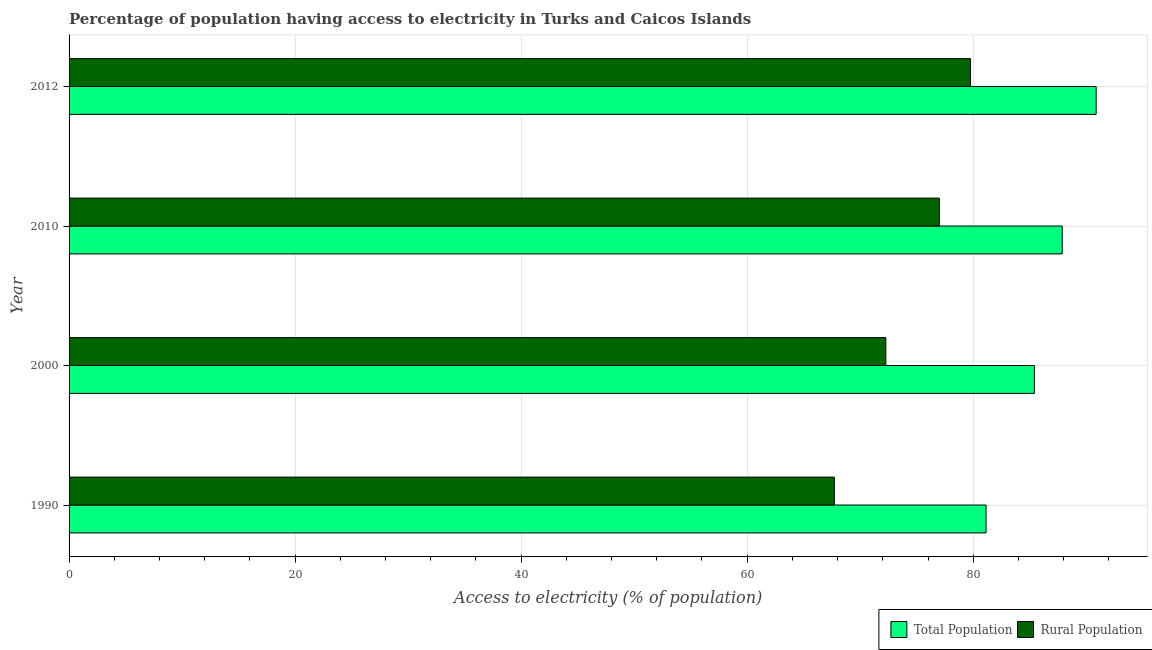How many groups of bars are there?
Give a very brief answer. 4. Are the number of bars on each tick of the Y-axis equal?
Your response must be concise. Yes. How many bars are there on the 2nd tick from the top?
Offer a very short reply. 2. How many bars are there on the 2nd tick from the bottom?
Keep it short and to the point. 2. What is the label of the 3rd group of bars from the top?
Offer a terse response. 2000. What is the percentage of rural population having access to electricity in 2010?
Provide a succinct answer. 77. Across all years, what is the maximum percentage of rural population having access to electricity?
Offer a terse response. 79.75. Across all years, what is the minimum percentage of population having access to electricity?
Keep it short and to the point. 81.14. In which year was the percentage of rural population having access to electricity minimum?
Keep it short and to the point. 1990. What is the total percentage of population having access to electricity in the graph?
Your answer should be compact. 345.3. What is the difference between the percentage of population having access to electricity in 1990 and that in 2000?
Your response must be concise. -4.28. What is the difference between the percentage of population having access to electricity in 2000 and the percentage of rural population having access to electricity in 2012?
Your answer should be very brief. 5.66. What is the average percentage of population having access to electricity per year?
Your response must be concise. 86.32. In the year 2000, what is the difference between the percentage of rural population having access to electricity and percentage of population having access to electricity?
Your answer should be compact. -13.15. In how many years, is the percentage of population having access to electricity greater than 60 %?
Give a very brief answer. 4. What is the ratio of the percentage of rural population having access to electricity in 1990 to that in 2012?
Your answer should be compact. 0.85. Is the percentage of rural population having access to electricity in 1990 less than that in 2000?
Give a very brief answer. Yes. Is the difference between the percentage of rural population having access to electricity in 1990 and 2010 greater than the difference between the percentage of population having access to electricity in 1990 and 2010?
Ensure brevity in your answer.  No. What is the difference between the highest and the second highest percentage of population having access to electricity?
Your response must be concise. 3. What is the difference between the highest and the lowest percentage of population having access to electricity?
Offer a very short reply. 9.74. In how many years, is the percentage of population having access to electricity greater than the average percentage of population having access to electricity taken over all years?
Your response must be concise. 2. What does the 2nd bar from the top in 2000 represents?
Offer a very short reply. Total Population. What does the 2nd bar from the bottom in 1990 represents?
Your response must be concise. Rural Population. How many years are there in the graph?
Your answer should be very brief. 4. Are the values on the major ticks of X-axis written in scientific E-notation?
Make the answer very short. No. Does the graph contain any zero values?
Keep it short and to the point. No. Does the graph contain grids?
Make the answer very short. Yes. How many legend labels are there?
Offer a very short reply. 2. How are the legend labels stacked?
Your response must be concise. Horizontal. What is the title of the graph?
Keep it short and to the point. Percentage of population having access to electricity in Turks and Caicos Islands. What is the label or title of the X-axis?
Offer a very short reply. Access to electricity (% of population). What is the label or title of the Y-axis?
Ensure brevity in your answer.  Year. What is the Access to electricity (% of population) of Total Population in 1990?
Provide a short and direct response. 81.14. What is the Access to electricity (% of population) of Rural Population in 1990?
Offer a very short reply. 67.71. What is the Access to electricity (% of population) in Total Population in 2000?
Your answer should be compact. 85.41. What is the Access to electricity (% of population) in Rural Population in 2000?
Give a very brief answer. 72.27. What is the Access to electricity (% of population) in Total Population in 2010?
Your answer should be very brief. 87.87. What is the Access to electricity (% of population) of Total Population in 2012?
Ensure brevity in your answer.  90.88. What is the Access to electricity (% of population) in Rural Population in 2012?
Keep it short and to the point. 79.75. Across all years, what is the maximum Access to electricity (% of population) of Total Population?
Make the answer very short. 90.88. Across all years, what is the maximum Access to electricity (% of population) in Rural Population?
Make the answer very short. 79.75. Across all years, what is the minimum Access to electricity (% of population) in Total Population?
Offer a very short reply. 81.14. Across all years, what is the minimum Access to electricity (% of population) of Rural Population?
Your response must be concise. 67.71. What is the total Access to electricity (% of population) of Total Population in the graph?
Keep it short and to the point. 345.3. What is the total Access to electricity (% of population) of Rural Population in the graph?
Provide a succinct answer. 296.73. What is the difference between the Access to electricity (% of population) in Total Population in 1990 and that in 2000?
Keep it short and to the point. -4.28. What is the difference between the Access to electricity (% of population) in Rural Population in 1990 and that in 2000?
Your answer should be very brief. -4.55. What is the difference between the Access to electricity (% of population) of Total Population in 1990 and that in 2010?
Your answer should be very brief. -6.74. What is the difference between the Access to electricity (% of population) of Rural Population in 1990 and that in 2010?
Your answer should be compact. -9.29. What is the difference between the Access to electricity (% of population) in Total Population in 1990 and that in 2012?
Keep it short and to the point. -9.74. What is the difference between the Access to electricity (% of population) in Rural Population in 1990 and that in 2012?
Provide a short and direct response. -12.04. What is the difference between the Access to electricity (% of population) in Total Population in 2000 and that in 2010?
Make the answer very short. -2.46. What is the difference between the Access to electricity (% of population) of Rural Population in 2000 and that in 2010?
Make the answer very short. -4.74. What is the difference between the Access to electricity (% of population) of Total Population in 2000 and that in 2012?
Offer a terse response. -5.46. What is the difference between the Access to electricity (% of population) of Rural Population in 2000 and that in 2012?
Ensure brevity in your answer.  -7.49. What is the difference between the Access to electricity (% of population) in Total Population in 2010 and that in 2012?
Provide a succinct answer. -3. What is the difference between the Access to electricity (% of population) in Rural Population in 2010 and that in 2012?
Provide a short and direct response. -2.75. What is the difference between the Access to electricity (% of population) in Total Population in 1990 and the Access to electricity (% of population) in Rural Population in 2000?
Your answer should be very brief. 8.87. What is the difference between the Access to electricity (% of population) in Total Population in 1990 and the Access to electricity (% of population) in Rural Population in 2010?
Offer a terse response. 4.14. What is the difference between the Access to electricity (% of population) of Total Population in 1990 and the Access to electricity (% of population) of Rural Population in 2012?
Offer a terse response. 1.38. What is the difference between the Access to electricity (% of population) in Total Population in 2000 and the Access to electricity (% of population) in Rural Population in 2010?
Your answer should be very brief. 8.41. What is the difference between the Access to electricity (% of population) in Total Population in 2000 and the Access to electricity (% of population) in Rural Population in 2012?
Offer a very short reply. 5.66. What is the difference between the Access to electricity (% of population) of Total Population in 2010 and the Access to electricity (% of population) of Rural Population in 2012?
Offer a very short reply. 8.12. What is the average Access to electricity (% of population) in Total Population per year?
Provide a succinct answer. 86.32. What is the average Access to electricity (% of population) of Rural Population per year?
Offer a very short reply. 74.18. In the year 1990, what is the difference between the Access to electricity (% of population) in Total Population and Access to electricity (% of population) in Rural Population?
Offer a very short reply. 13.42. In the year 2000, what is the difference between the Access to electricity (% of population) of Total Population and Access to electricity (% of population) of Rural Population?
Your response must be concise. 13.15. In the year 2010, what is the difference between the Access to electricity (% of population) of Total Population and Access to electricity (% of population) of Rural Population?
Provide a short and direct response. 10.87. In the year 2012, what is the difference between the Access to electricity (% of population) of Total Population and Access to electricity (% of population) of Rural Population?
Ensure brevity in your answer.  11.12. What is the ratio of the Access to electricity (% of population) in Total Population in 1990 to that in 2000?
Give a very brief answer. 0.95. What is the ratio of the Access to electricity (% of population) of Rural Population in 1990 to that in 2000?
Offer a very short reply. 0.94. What is the ratio of the Access to electricity (% of population) of Total Population in 1990 to that in 2010?
Offer a terse response. 0.92. What is the ratio of the Access to electricity (% of population) of Rural Population in 1990 to that in 2010?
Make the answer very short. 0.88. What is the ratio of the Access to electricity (% of population) in Total Population in 1990 to that in 2012?
Your answer should be compact. 0.89. What is the ratio of the Access to electricity (% of population) of Rural Population in 1990 to that in 2012?
Make the answer very short. 0.85. What is the ratio of the Access to electricity (% of population) of Rural Population in 2000 to that in 2010?
Your answer should be very brief. 0.94. What is the ratio of the Access to electricity (% of population) in Total Population in 2000 to that in 2012?
Offer a terse response. 0.94. What is the ratio of the Access to electricity (% of population) of Rural Population in 2000 to that in 2012?
Your answer should be compact. 0.91. What is the ratio of the Access to electricity (% of population) in Rural Population in 2010 to that in 2012?
Offer a very short reply. 0.97. What is the difference between the highest and the second highest Access to electricity (% of population) of Total Population?
Ensure brevity in your answer.  3. What is the difference between the highest and the second highest Access to electricity (% of population) in Rural Population?
Offer a very short reply. 2.75. What is the difference between the highest and the lowest Access to electricity (% of population) in Total Population?
Your response must be concise. 9.74. What is the difference between the highest and the lowest Access to electricity (% of population) in Rural Population?
Provide a succinct answer. 12.04. 